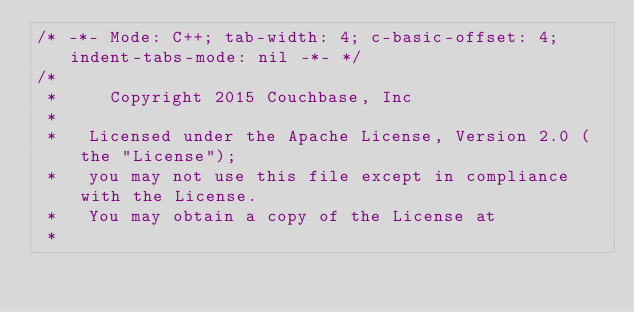<code> <loc_0><loc_0><loc_500><loc_500><_C++_>/* -*- Mode: C++; tab-width: 4; c-basic-offset: 4; indent-tabs-mode: nil -*- */
/*
 *     Copyright 2015 Couchbase, Inc
 *
 *   Licensed under the Apache License, Version 2.0 (the "License");
 *   you may not use this file except in compliance with the License.
 *   You may obtain a copy of the License at
 *</code> 